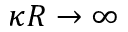Convert formula to latex. <formula><loc_0><loc_0><loc_500><loc_500>\kappa R \rightarrow \infty</formula> 